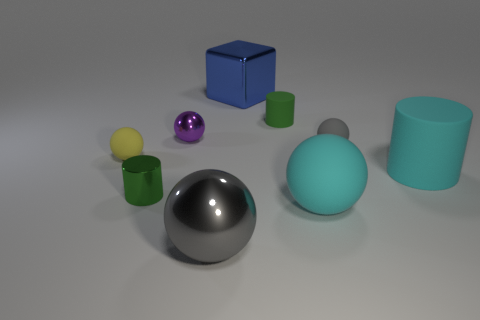How many balls have the same size as the cyan cylinder?
Provide a succinct answer. 2. What is the shape of the green thing to the left of the big blue shiny object?
Offer a very short reply. Cylinder. Is the number of tiny purple spheres less than the number of brown objects?
Provide a short and direct response. No. Is there any other thing that is the same color as the big matte cylinder?
Give a very brief answer. Yes. What size is the green object left of the gray shiny thing?
Offer a very short reply. Small. Are there more small gray spheres than tiny metallic things?
Your answer should be compact. No. What material is the big blue cube?
Provide a short and direct response. Metal. How many other things are there of the same material as the big cyan sphere?
Provide a short and direct response. 4. How many purple things are there?
Offer a terse response. 1. There is a cyan object that is the same shape as the purple object; what is it made of?
Keep it short and to the point. Rubber. 